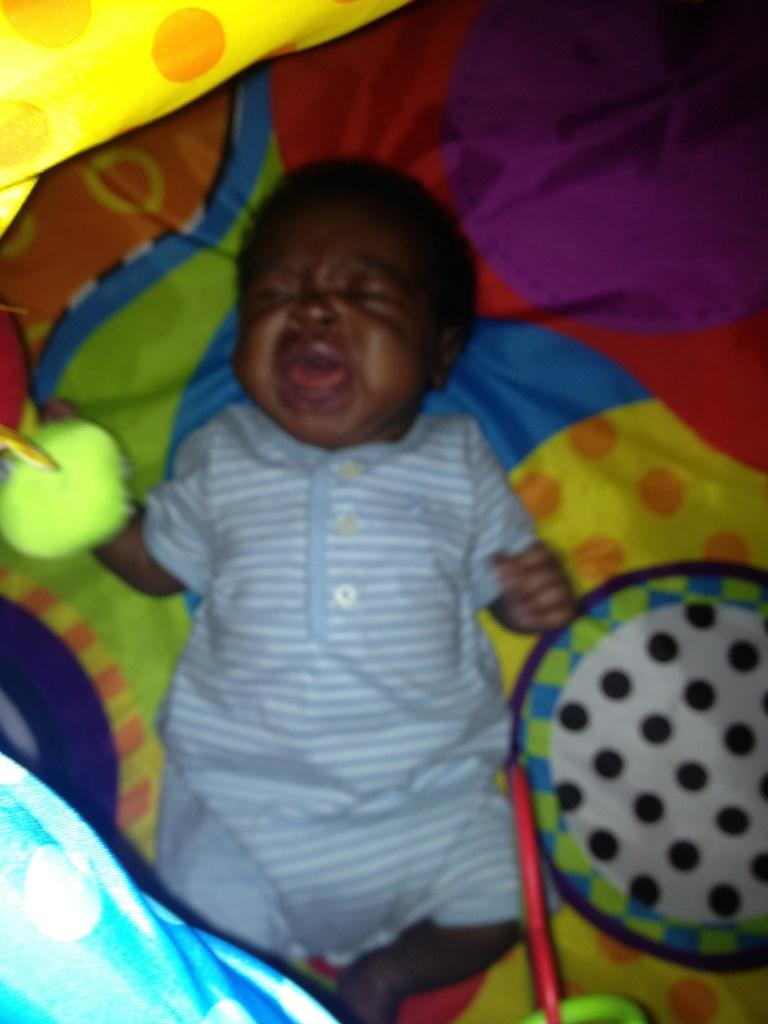What is the main subject of the image? The main subject of the image is a baby. What is the baby doing in the image? The baby is crying in the image. Where is the baby located in the image? The baby is lying on a bed in the image. What type of wealth is the baby holding in the image? There is no indication of wealth or any objects being held by the baby in the image. What title does the baby have in the image? There is no title associated with the baby in the image. 